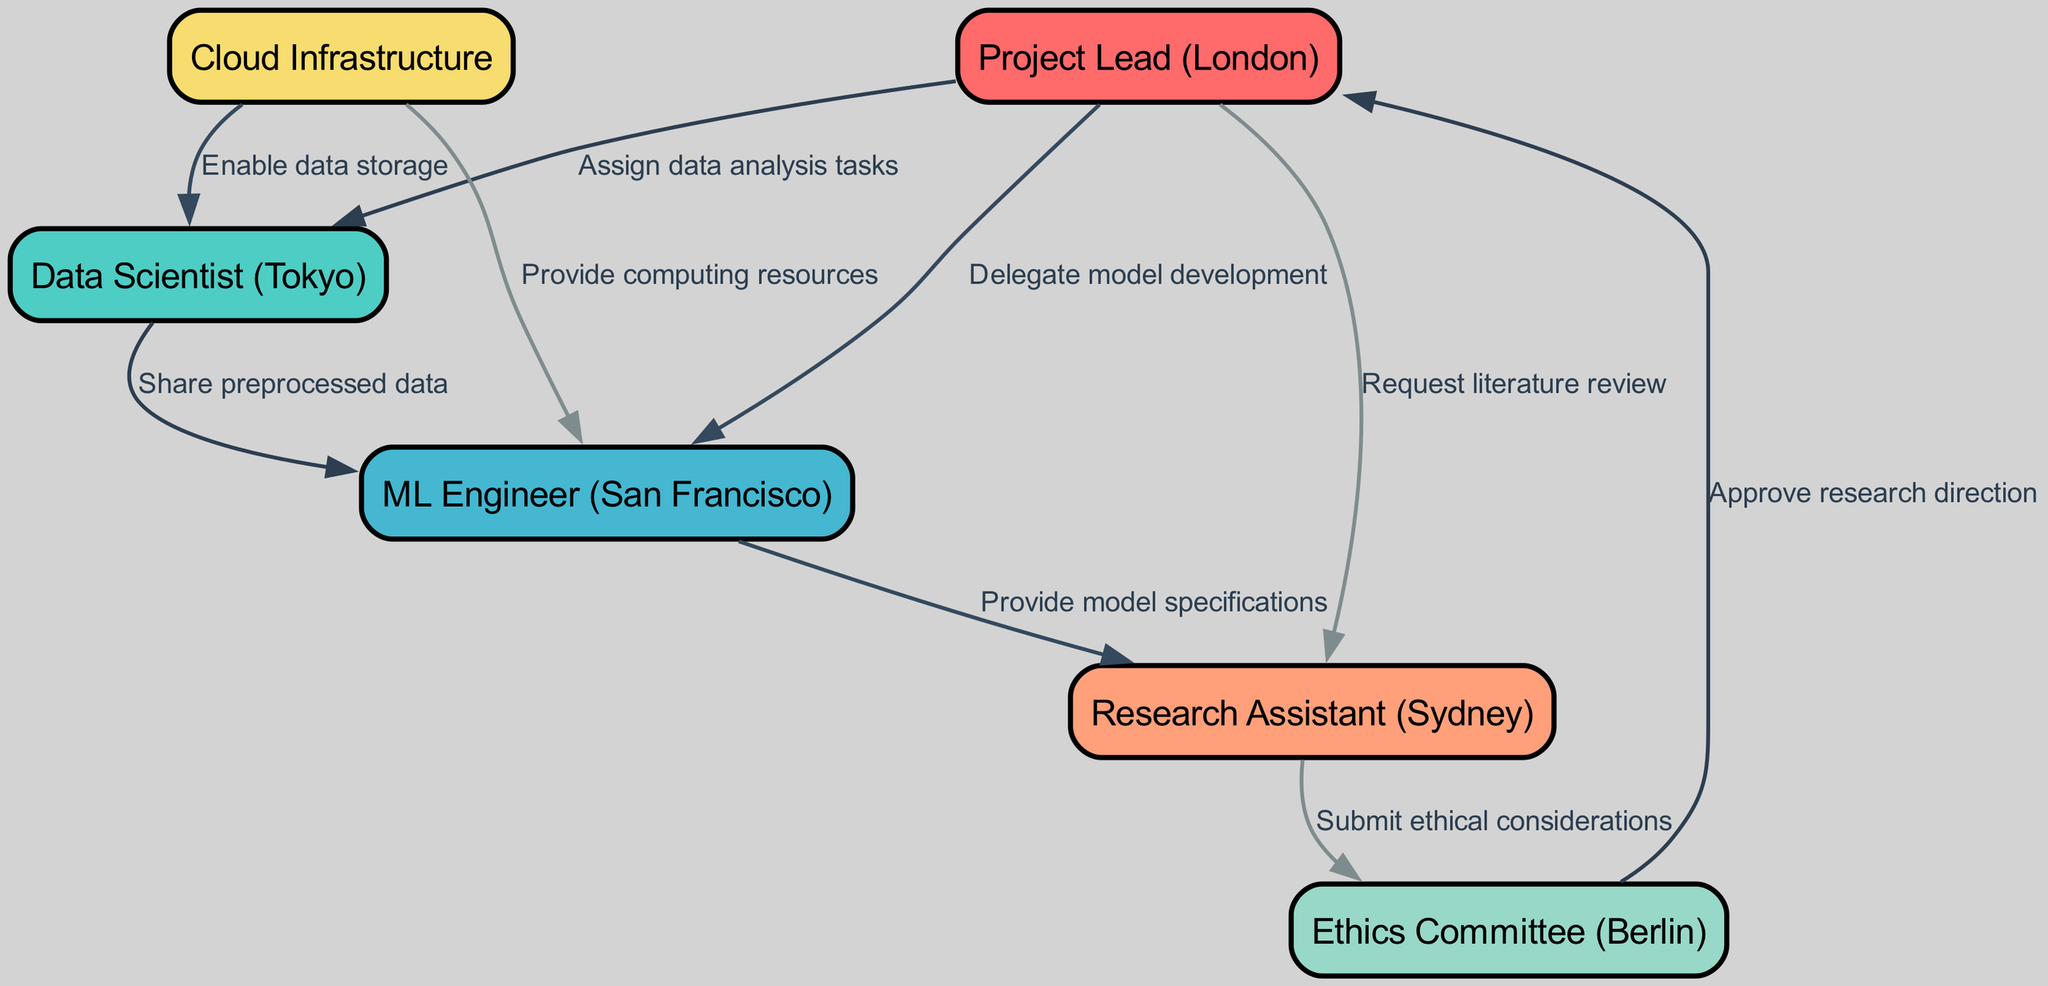What is the number of nodes in the graph? The graph contains a set of entities represented as nodes. By counting the elements in the nodes list provided, we find that there are six distinct nodes: Project Lead, Data Scientist, ML Engineer, Research Assistant, Ethics Committee, and Cloud Infrastructure.
Answer: 6 Who is responsible for enabling data storage? The edges in the graph indicate relationships and responsibilities among nodes. The edge from Cloud Infrastructure to Data Scientist is labeled "Enable data storage," which specifies that the Cloud Infrastructure node is responsible for this task.
Answer: Cloud Infrastructure What task is assigned to the ML Engineer by the Project Lead? The directed edge from Project Lead to ML Engineer is labeled "Delegate model development." This indicates that the Project Lead entrusts the ML Engineer with the responsibility of model development within the collaboration workflow.
Answer: Delegate model development Which node submits ethical considerations? The directed edge from Research Assistant to Ethics Committee reveals that the Research Assistant submits ethical considerations. This relationship identifies the Research Assistant's responsibility in the workflow, leading to the review by the Ethics Committee.
Answer: Submit ethical considerations What is the role of the Ethics Committee in this collaboration? The Ethics Committee has a critical role in the workflow as it is the recipient of ethical considerations submitted by the Research Assistant. Additionally, it approves the research direction based on those considerations, indicating its evaluative role in the project.
Answer: Approve research direction How many edges are in the graph? The number of edges indicates the relationships or communication channels between the nodes. By counting the edges provided, we see that there are a total of eight edges representing the various interactions and dependencies among the nodes.
Answer: 8 Which node shares preprocessed data with the ML Engineer? The directed edge from Data Scientist to ML Engineer is labeled "Share preprocessed data." This relationship indicates that the Data Scientist is responsible for providing the preprocessed data needed for the ML Engineer's tasks.
Answer: Data Scientist Who is tasked with providing model specifications? The edge that connects ML Engineer to Research Assistant is labeled "Provide model specifications." This means that the ML Engineer is accountable for providing the necessary specifications for the models to the Research Assistant as part of their collaboration.
Answer: Provide model specifications 